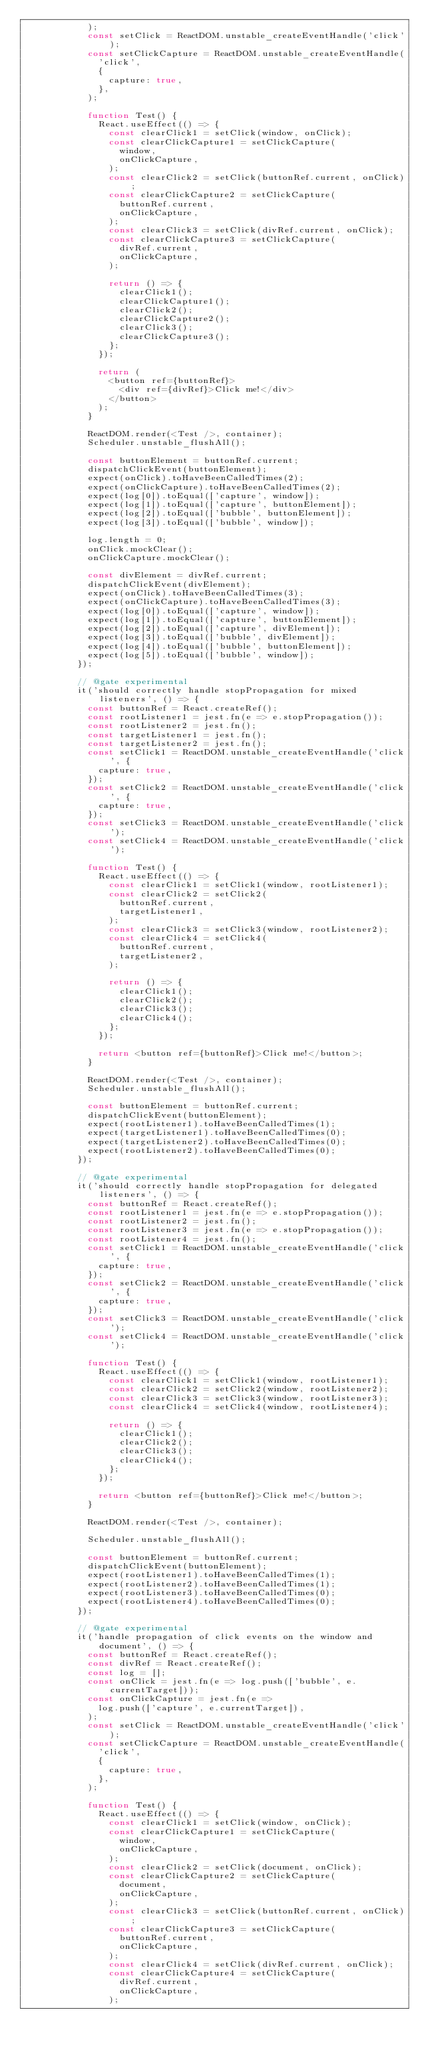<code> <loc_0><loc_0><loc_500><loc_500><_JavaScript_>            );
            const setClick = ReactDOM.unstable_createEventHandle('click');
            const setClickCapture = ReactDOM.unstable_createEventHandle(
              'click',
              {
                capture: true,
              },
            );

            function Test() {
              React.useEffect(() => {
                const clearClick1 = setClick(window, onClick);
                const clearClickCapture1 = setClickCapture(
                  window,
                  onClickCapture,
                );
                const clearClick2 = setClick(buttonRef.current, onClick);
                const clearClickCapture2 = setClickCapture(
                  buttonRef.current,
                  onClickCapture,
                );
                const clearClick3 = setClick(divRef.current, onClick);
                const clearClickCapture3 = setClickCapture(
                  divRef.current,
                  onClickCapture,
                );

                return () => {
                  clearClick1();
                  clearClickCapture1();
                  clearClick2();
                  clearClickCapture2();
                  clearClick3();
                  clearClickCapture3();
                };
              });

              return (
                <button ref={buttonRef}>
                  <div ref={divRef}>Click me!</div>
                </button>
              );
            }

            ReactDOM.render(<Test />, container);
            Scheduler.unstable_flushAll();

            const buttonElement = buttonRef.current;
            dispatchClickEvent(buttonElement);
            expect(onClick).toHaveBeenCalledTimes(2);
            expect(onClickCapture).toHaveBeenCalledTimes(2);
            expect(log[0]).toEqual(['capture', window]);
            expect(log[1]).toEqual(['capture', buttonElement]);
            expect(log[2]).toEqual(['bubble', buttonElement]);
            expect(log[3]).toEqual(['bubble', window]);

            log.length = 0;
            onClick.mockClear();
            onClickCapture.mockClear();

            const divElement = divRef.current;
            dispatchClickEvent(divElement);
            expect(onClick).toHaveBeenCalledTimes(3);
            expect(onClickCapture).toHaveBeenCalledTimes(3);
            expect(log[0]).toEqual(['capture', window]);
            expect(log[1]).toEqual(['capture', buttonElement]);
            expect(log[2]).toEqual(['capture', divElement]);
            expect(log[3]).toEqual(['bubble', divElement]);
            expect(log[4]).toEqual(['bubble', buttonElement]);
            expect(log[5]).toEqual(['bubble', window]);
          });

          // @gate experimental
          it('should correctly handle stopPropagation for mixed listeners', () => {
            const buttonRef = React.createRef();
            const rootListener1 = jest.fn(e => e.stopPropagation());
            const rootListener2 = jest.fn();
            const targetListener1 = jest.fn();
            const targetListener2 = jest.fn();
            const setClick1 = ReactDOM.unstable_createEventHandle('click', {
              capture: true,
            });
            const setClick2 = ReactDOM.unstable_createEventHandle('click', {
              capture: true,
            });
            const setClick3 = ReactDOM.unstable_createEventHandle('click');
            const setClick4 = ReactDOM.unstable_createEventHandle('click');

            function Test() {
              React.useEffect(() => {
                const clearClick1 = setClick1(window, rootListener1);
                const clearClick2 = setClick2(
                  buttonRef.current,
                  targetListener1,
                );
                const clearClick3 = setClick3(window, rootListener2);
                const clearClick4 = setClick4(
                  buttonRef.current,
                  targetListener2,
                );

                return () => {
                  clearClick1();
                  clearClick2();
                  clearClick3();
                  clearClick4();
                };
              });

              return <button ref={buttonRef}>Click me!</button>;
            }

            ReactDOM.render(<Test />, container);
            Scheduler.unstable_flushAll();

            const buttonElement = buttonRef.current;
            dispatchClickEvent(buttonElement);
            expect(rootListener1).toHaveBeenCalledTimes(1);
            expect(targetListener1).toHaveBeenCalledTimes(0);
            expect(targetListener2).toHaveBeenCalledTimes(0);
            expect(rootListener2).toHaveBeenCalledTimes(0);
          });

          // @gate experimental
          it('should correctly handle stopPropagation for delegated listeners', () => {
            const buttonRef = React.createRef();
            const rootListener1 = jest.fn(e => e.stopPropagation());
            const rootListener2 = jest.fn();
            const rootListener3 = jest.fn(e => e.stopPropagation());
            const rootListener4 = jest.fn();
            const setClick1 = ReactDOM.unstable_createEventHandle('click', {
              capture: true,
            });
            const setClick2 = ReactDOM.unstable_createEventHandle('click', {
              capture: true,
            });
            const setClick3 = ReactDOM.unstable_createEventHandle('click');
            const setClick4 = ReactDOM.unstable_createEventHandle('click');

            function Test() {
              React.useEffect(() => {
                const clearClick1 = setClick1(window, rootListener1);
                const clearClick2 = setClick2(window, rootListener2);
                const clearClick3 = setClick3(window, rootListener3);
                const clearClick4 = setClick4(window, rootListener4);

                return () => {
                  clearClick1();
                  clearClick2();
                  clearClick3();
                  clearClick4();
                };
              });

              return <button ref={buttonRef}>Click me!</button>;
            }

            ReactDOM.render(<Test />, container);

            Scheduler.unstable_flushAll();

            const buttonElement = buttonRef.current;
            dispatchClickEvent(buttonElement);
            expect(rootListener1).toHaveBeenCalledTimes(1);
            expect(rootListener2).toHaveBeenCalledTimes(1);
            expect(rootListener3).toHaveBeenCalledTimes(0);
            expect(rootListener4).toHaveBeenCalledTimes(0);
          });

          // @gate experimental
          it('handle propagation of click events on the window and document', () => {
            const buttonRef = React.createRef();
            const divRef = React.createRef();
            const log = [];
            const onClick = jest.fn(e => log.push(['bubble', e.currentTarget]));
            const onClickCapture = jest.fn(e =>
              log.push(['capture', e.currentTarget]),
            );
            const setClick = ReactDOM.unstable_createEventHandle('click');
            const setClickCapture = ReactDOM.unstable_createEventHandle(
              'click',
              {
                capture: true,
              },
            );

            function Test() {
              React.useEffect(() => {
                const clearClick1 = setClick(window, onClick);
                const clearClickCapture1 = setClickCapture(
                  window,
                  onClickCapture,
                );
                const clearClick2 = setClick(document, onClick);
                const clearClickCapture2 = setClickCapture(
                  document,
                  onClickCapture,
                );
                const clearClick3 = setClick(buttonRef.current, onClick);
                const clearClickCapture3 = setClickCapture(
                  buttonRef.current,
                  onClickCapture,
                );
                const clearClick4 = setClick(divRef.current, onClick);
                const clearClickCapture4 = setClickCapture(
                  divRef.current,
                  onClickCapture,
                );
</code> 